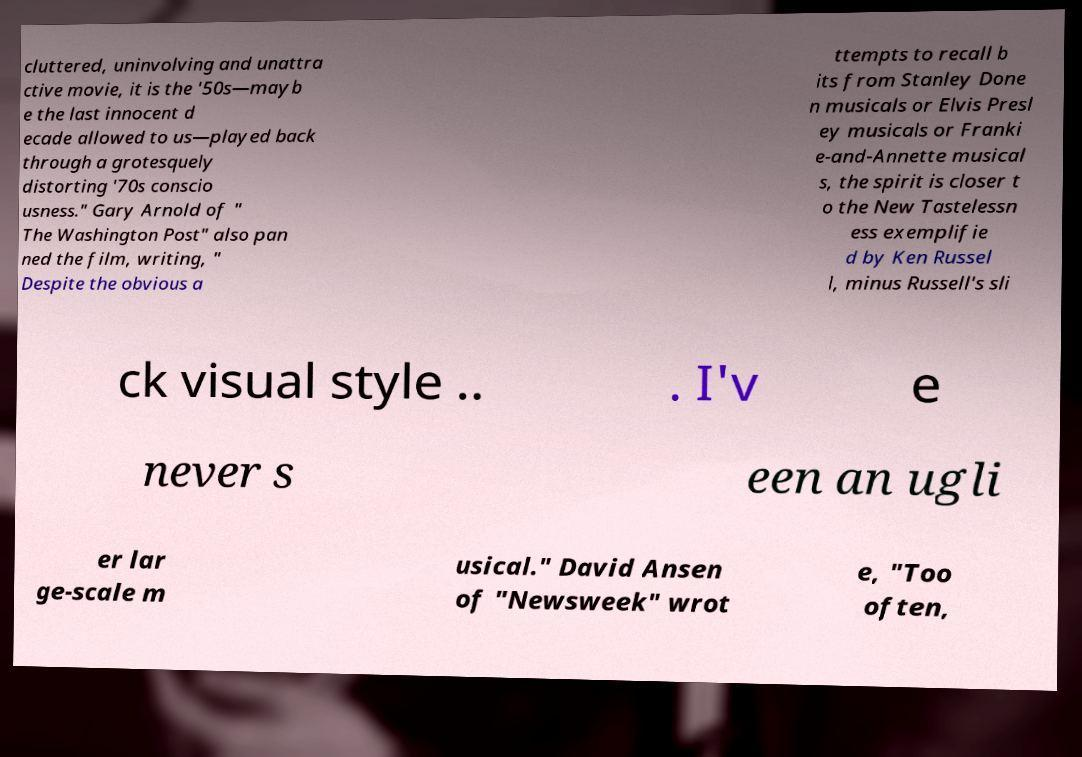There's text embedded in this image that I need extracted. Can you transcribe it verbatim? cluttered, uninvolving and unattra ctive movie, it is the '50s—mayb e the last innocent d ecade allowed to us—played back through a grotesquely distorting '70s conscio usness." Gary Arnold of " The Washington Post" also pan ned the film, writing, " Despite the obvious a ttempts to recall b its from Stanley Done n musicals or Elvis Presl ey musicals or Franki e-and-Annette musical s, the spirit is closer t o the New Tastelessn ess exemplifie d by Ken Russel l, minus Russell's sli ck visual style .. . I'v e never s een an ugli er lar ge-scale m usical." David Ansen of "Newsweek" wrot e, "Too often, 